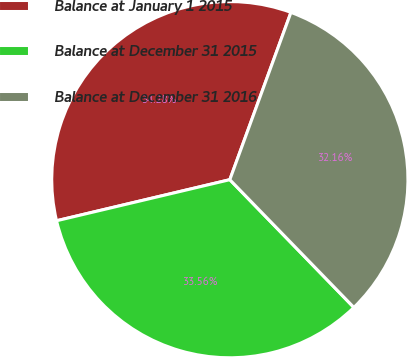Convert chart to OTSL. <chart><loc_0><loc_0><loc_500><loc_500><pie_chart><fcel>Balance at January 1 2015<fcel>Balance at December 31 2015<fcel>Balance at December 31 2016<nl><fcel>34.28%<fcel>33.56%<fcel>32.16%<nl></chart> 